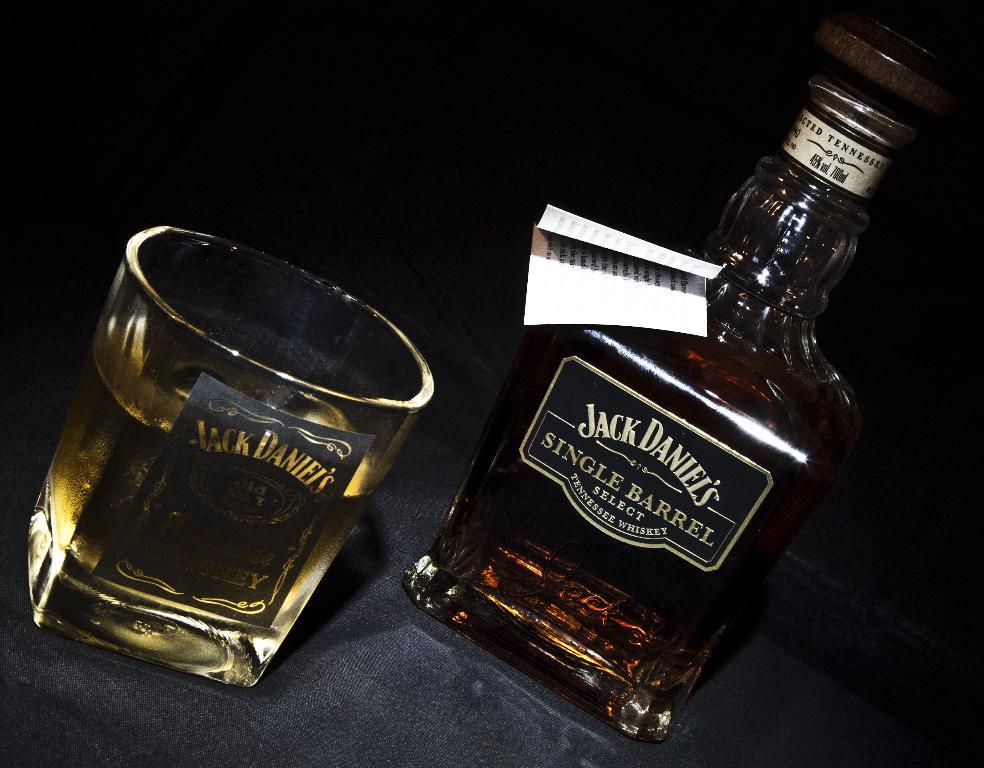What brand of whiskey is this?
Ensure brevity in your answer.  Jack daniel's. 